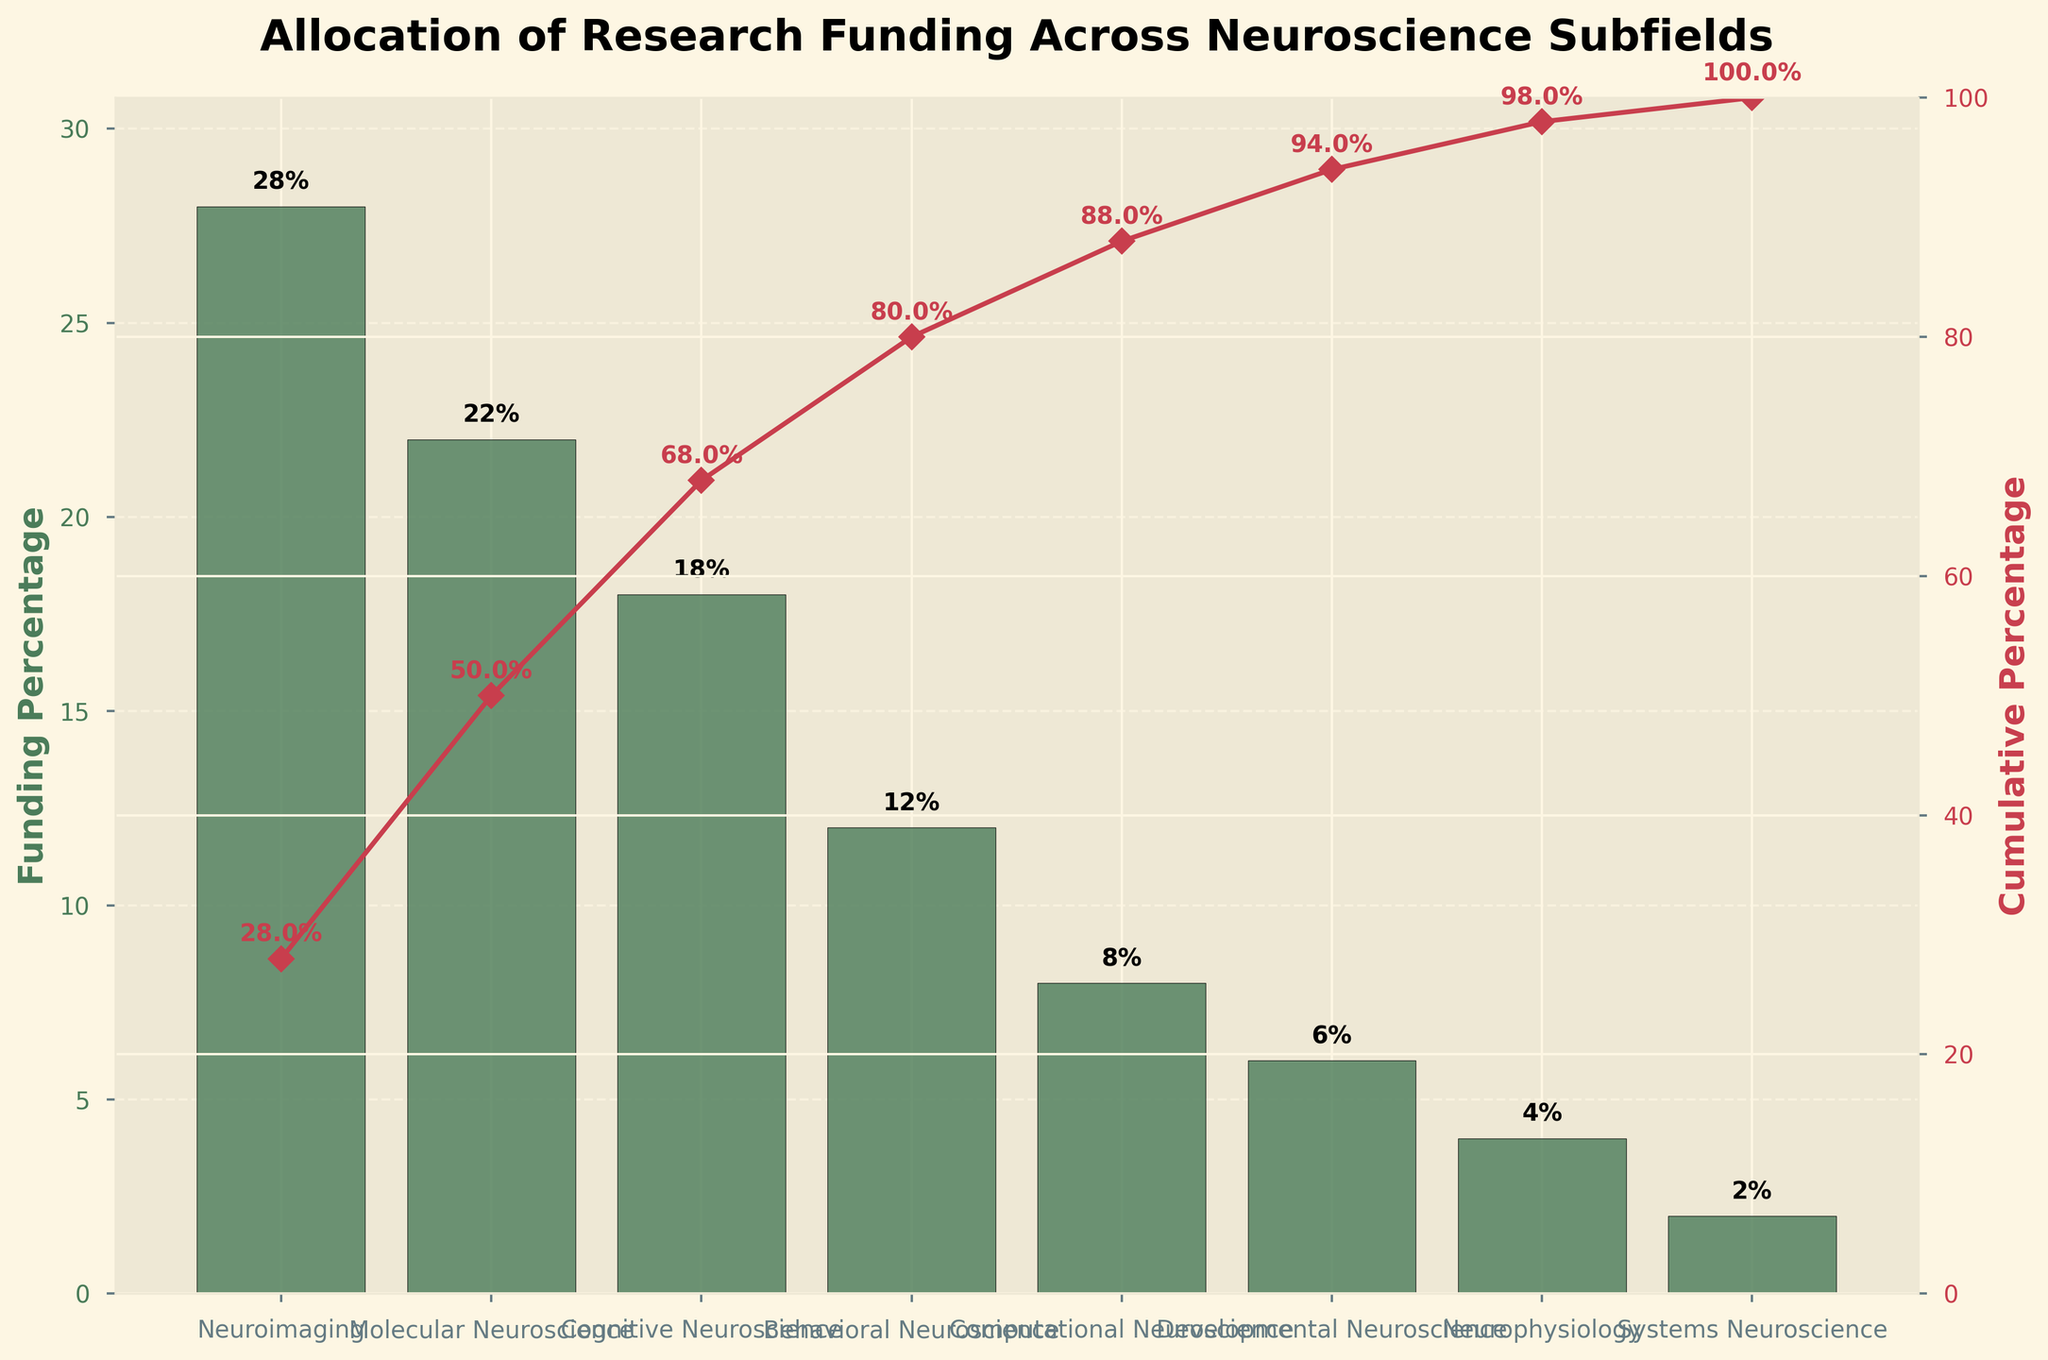what is the title of the figure? The title of the figure is located at the top and summarises the main focus of the chart. In this case, the title reads 'Allocation of Research Funding Across Neuroscience Subfields'.
Answer: Allocation of Research Funding Across Neuroscience Subfields What is the percentage allocated to Neuroimaging? The figures for each subfield are given as bars with percentage labels on top. The bar for Neuroimaging shows a percentage of 28%.
Answer: 28% Which subfield has the lowest funding percentage? By looking at the bars, the shortest bar represents the subfield with the lowest funding percentage. Systems Neuroscience has the shortest bar.
Answer: Systems Neuroscience What is the cumulative percentage after the top three subfields? To find the cumulative percentage, add the individual percentages of the top three subfields. Neuroimaging (28%) + Molecular Neuroscience (22%) + Cognitive Neuroscience (18%) = 68%.
Answer: 68% How does the funding for Computational Neuroscience compare to Behavioral Neuroscience? The heights of the bars indicate the percentages. Computational Neuroscience has 8%, and Behavioral Neuroscience has 12%.
Answer: Behavioral Neuroscience has more funding What cumulative percentage does Neurophysiology reach in the chart? The cumulative percentage line shows the running total of percentages. For Neurophysiology, it is 92%.
Answer: 92% Which subfields make up more than 70% of the total funding allocated? To find which subfields contribute to more than 70%, examine the cumulative percentage line. The top four subfields (Neuroimaging, Molecular Neuroscience, Cognitive Neuroscience, Behavioral Neuroscience) total 80%.
Answer: Neuroimaging, Molecular Neuroscience, Cognitive Neuroscience, Behavioral Neuroscience What is the difference in funding percentage between the highest and lowest funded subfields? Subtract the lowest funding percentage (2% for Systems Neuroscience) from the highest (28% for Neuroimaging). The difference is 28% - 2% = 26%.
Answer: 26% How many subfields have funding percentages above 10%? The bars that exceed the 10% mark come under the subfields: Neuroimaging, Molecular Neuroscience, Cognitive Neuroscience, and Behavioral Neuroscience, which make a total of 4 subfields.
Answer: 4 